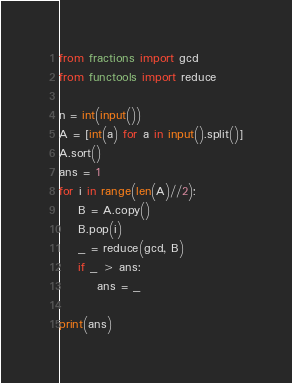Convert code to text. <code><loc_0><loc_0><loc_500><loc_500><_Python_>from fractions import gcd
from functools import reduce

n = int(input())
A = [int(a) for a in input().split()]
A.sort()
ans = 1
for i in range(len(A)//2):
    B = A.copy()
    B.pop(i)
    _ = reduce(gcd, B)
    if _ > ans:
        ans = _
        
print(ans)</code> 